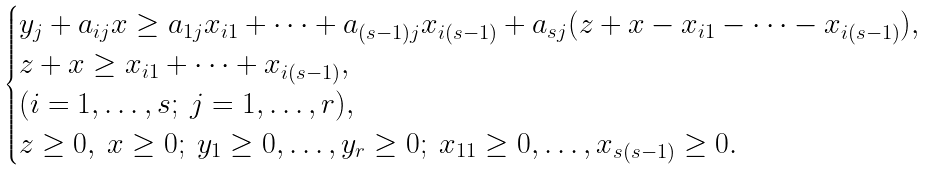Convert formula to latex. <formula><loc_0><loc_0><loc_500><loc_500>\begin{cases} y _ { j } + a _ { i j } x \geq a _ { 1 j } x _ { i 1 } + \cdots + a _ { ( s - 1 ) j } x _ { i ( s - 1 ) } + a _ { s j } ( z + x - x _ { i 1 } - \cdots - x _ { i ( s - 1 ) } ) , \\ z + x \geq x _ { i 1 } + \cdots + x _ { i ( s - 1 ) } , \\ ( i = 1 , \dots , s ; \ j = 1 , \dots , r ) , \\ z \geq 0 , \ x \geq 0 ; \ y _ { 1 } \geq 0 , \dots , y _ { r } \geq 0 ; \ x _ { 1 1 } \geq 0 , \dots , x _ { s ( s - 1 ) } \geq 0 . \end{cases}</formula> 